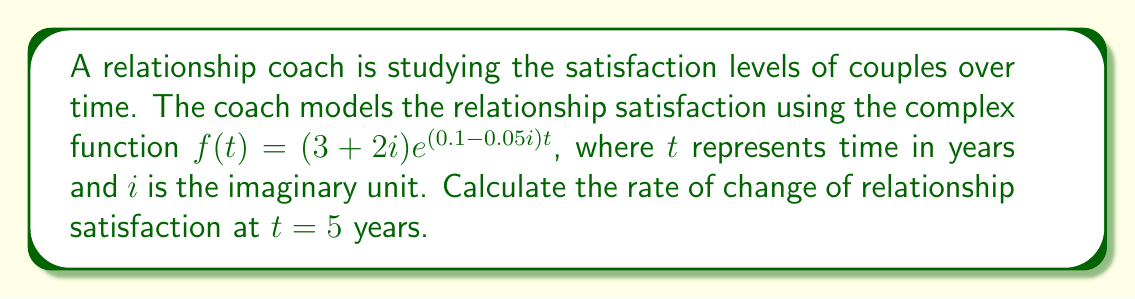Can you answer this question? To find the rate of change of relationship satisfaction at $t=5$ years, we need to calculate the derivative of the given function $f(t)$ and evaluate it at $t=5$.

1) The given function is $f(t) = (3+2i)e^{(0.1-0.05i)t}$

2) To find the derivative, we use the chain rule:
   $$f'(t) = (3+2i) \cdot (0.1-0.05i) \cdot e^{(0.1-0.05i)t}$$

3) Now, we need to evaluate $f'(5)$:
   $$f'(5) = (3+2i) \cdot (0.1-0.05i) \cdot e^{(0.1-0.05i)5}$$

4) Let's calculate $e^{(0.1-0.05i)5}$ first:
   $$(0.1-0.05i)5 = 0.5-0.25i$$
   $$e^{0.5-0.25i} = e^{0.5}(\cos(-0.25) + i\sin(-0.25))$$

5) Using a calculator:
   $$e^{0.5} \approx 1.6487$$
   $$\cos(-0.25) \approx 0.9689$$
   $$\sin(-0.25) \approx -0.2474$$

6) Substituting these values:
   $$f'(5) \approx (3+2i) \cdot (0.1-0.05i) \cdot 1.6487(0.9689 - 0.2474i)$$

7) Multiplying the complex numbers:
   $$(3+2i) \cdot (0.1-0.05i) = (0.3+0.2i)(-0.05i) = 0.3 + 0.1i$$

8) Final calculation:
   $$f'(5) \approx (0.3 + 0.1i) \cdot 1.6487(0.9689 - 0.2474i)$$
   $$\approx (0.3 + 0.1i) \cdot (1.5975 - 0.4079i)$$
   $$\approx 0.4793 - 0.1224i + 0.1598i - 0.0408$$
   $$\approx 0.4385 + 0.0374i$$

This complex number represents the rate of change in relationship satisfaction at $t=5$ years.
Answer: The rate of change of relationship satisfaction at $t=5$ years is approximately $0.4385 + 0.0374i$. 